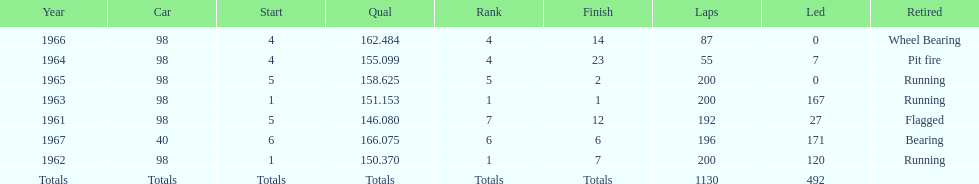Previous to 1965, when did jones have a number 5 start at the indy 500? 1961. I'm looking to parse the entire table for insights. Could you assist me with that? {'header': ['Year', 'Car', 'Start', 'Qual', 'Rank', 'Finish', 'Laps', 'Led', 'Retired'], 'rows': [['1966', '98', '4', '162.484', '4', '14', '87', '0', 'Wheel Bearing'], ['1964', '98', '4', '155.099', '4', '23', '55', '7', 'Pit fire'], ['1965', '98', '5', '158.625', '5', '2', '200', '0', 'Running'], ['1963', '98', '1', '151.153', '1', '1', '200', '167', 'Running'], ['1961', '98', '5', '146.080', '7', '12', '192', '27', 'Flagged'], ['1967', '40', '6', '166.075', '6', '6', '196', '171', 'Bearing'], ['1962', '98', '1', '150.370', '1', '7', '200', '120', 'Running'], ['Totals', 'Totals', 'Totals', 'Totals', 'Totals', 'Totals', '1130', '492', '']]} 